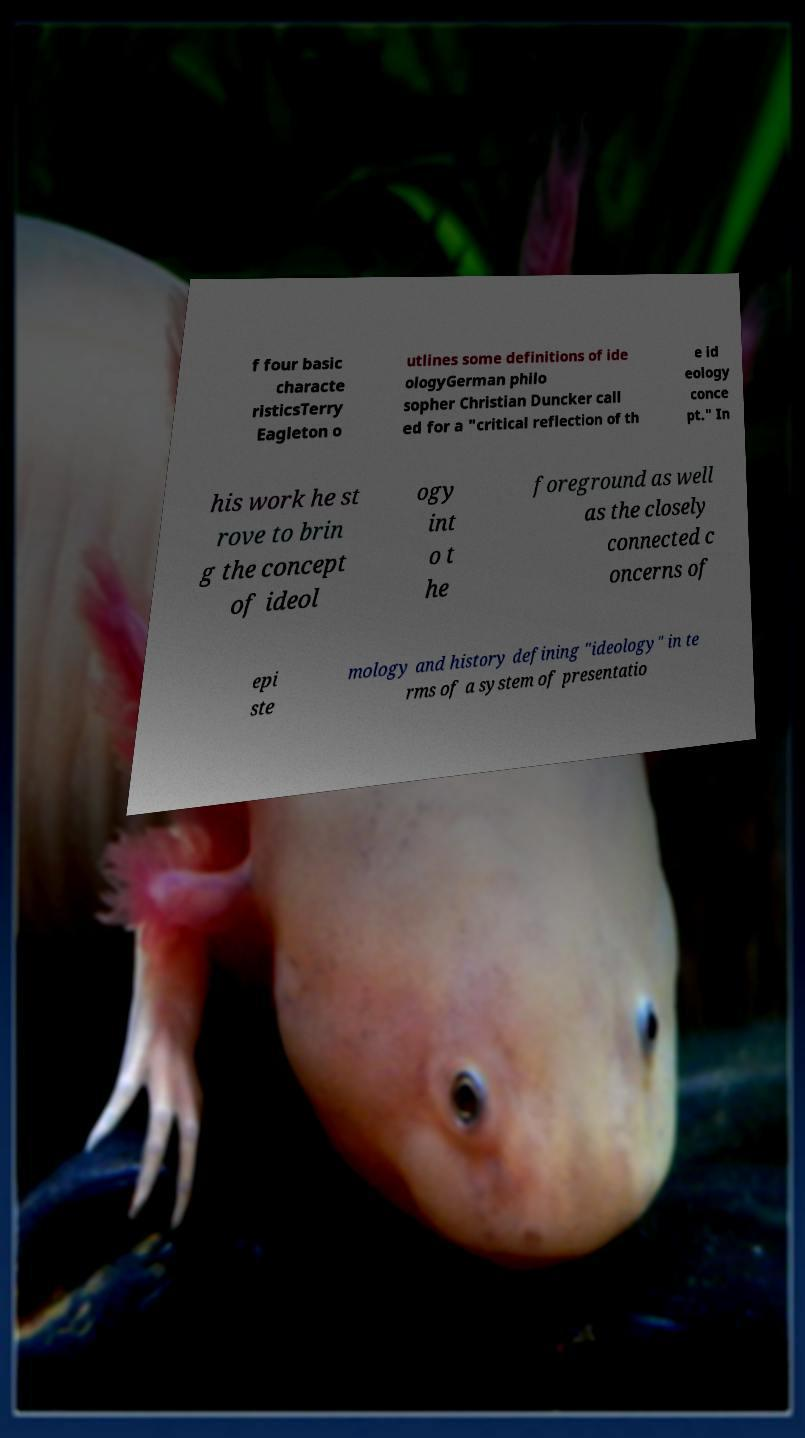Please identify and transcribe the text found in this image. f four basic characte risticsTerry Eagleton o utlines some definitions of ide ologyGerman philo sopher Christian Duncker call ed for a "critical reflection of th e id eology conce pt." In his work he st rove to brin g the concept of ideol ogy int o t he foreground as well as the closely connected c oncerns of epi ste mology and history defining "ideology" in te rms of a system of presentatio 